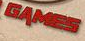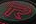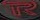What text is displayed in these images sequentially, separated by a semicolon? GAMES; R; R 